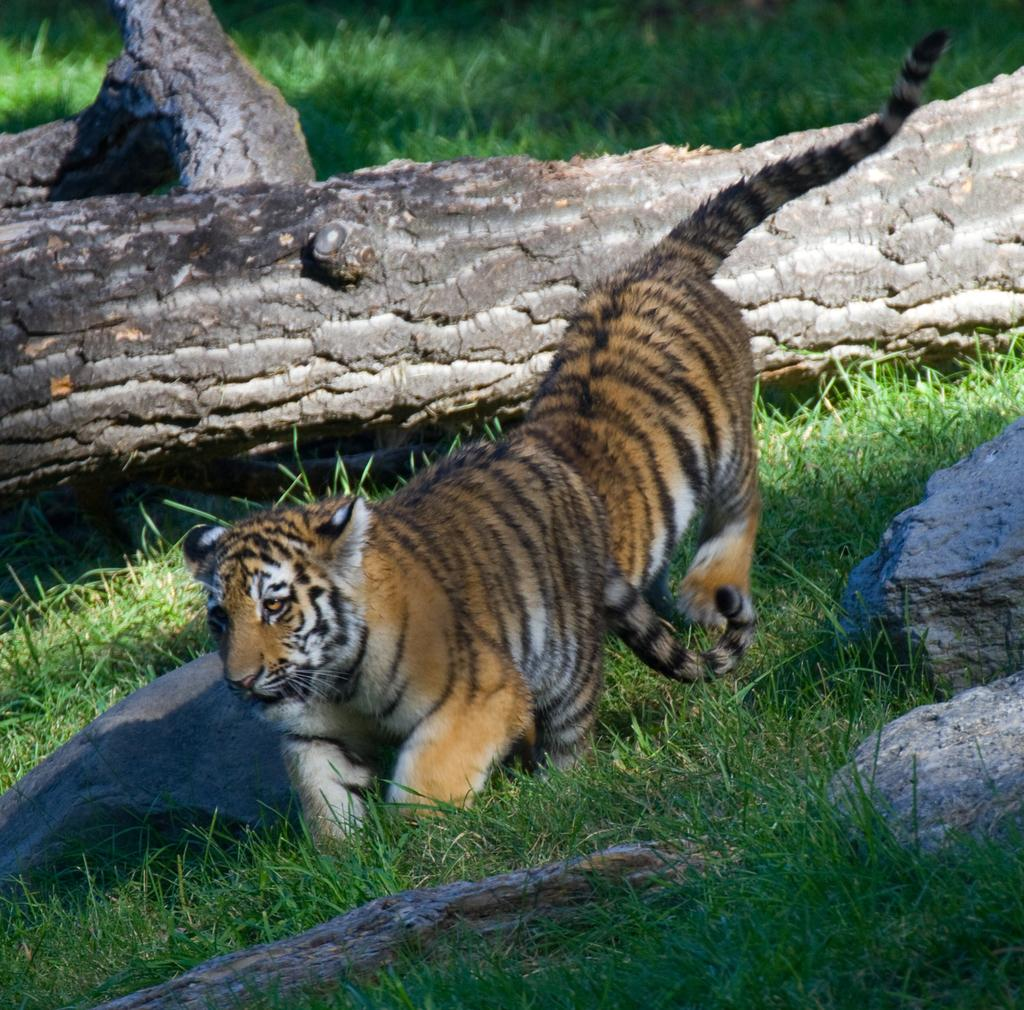What type of animal is in the image? There is a tiger in the image. What type of terrain is visible in the image? There is grass and rocks in the image. What color is the silver patch on the tiger's bed in the image? There is no silver patch or bed present in the image; it features a tiger in a grassy and rocky environment. 